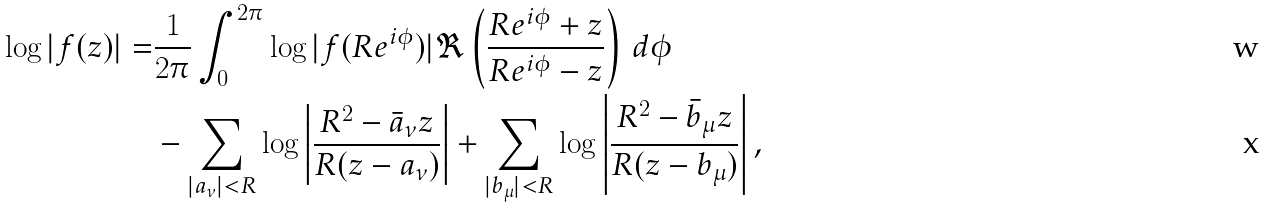<formula> <loc_0><loc_0><loc_500><loc_500>\log | f ( z ) | = & \frac { 1 } { 2 \pi } \int _ { 0 } ^ { 2 \pi } \log | f ( R e ^ { i \phi } ) | \Re \left ( \frac { R e ^ { i \phi } + z } { R e ^ { i \phi } - z } \right ) \, d \phi \\ & - \sum _ { | a _ { \nu } | < R } \log \left | \frac { R ^ { 2 } - \bar { a } _ { \nu } z } { R ( z - a _ { \nu } ) } \right | + \sum _ { | b _ { \mu } | < R } \log \left | \frac { R ^ { 2 } - \bar { b } _ { \mu } z } { R ( z - b _ { \mu } ) } \right | ,</formula> 